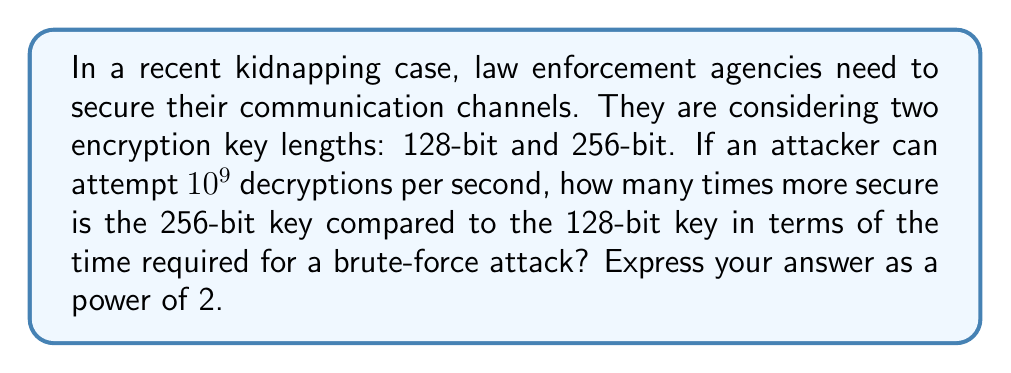Could you help me with this problem? Let's approach this step-by-step:

1) For a brute-force attack, an attacker needs to try all possible keys in the worst case.

2) For a 128-bit key, there are $2^{128}$ possible keys.
   For a 256-bit key, there are $2^{256}$ possible keys.

3) Time required for a brute-force attack:
   For 128-bit key: $T_{128} = \frac{2^{128}}{10^9}$ seconds
   For 256-bit key: $T_{256} = \frac{2^{256}}{10^9}$ seconds

4) The ratio of these times gives us how much more secure the 256-bit key is:

   $$\frac{T_{256}}{T_{128}} = \frac{2^{256}/10^9}{2^{128}/10^9} = \frac{2^{256}}{2^{128}} = 2^{256-128} = 2^{128}$$

5) Therefore, the 256-bit key is $2^{128}$ times more secure than the 128-bit key.
Answer: $2^{128}$ 